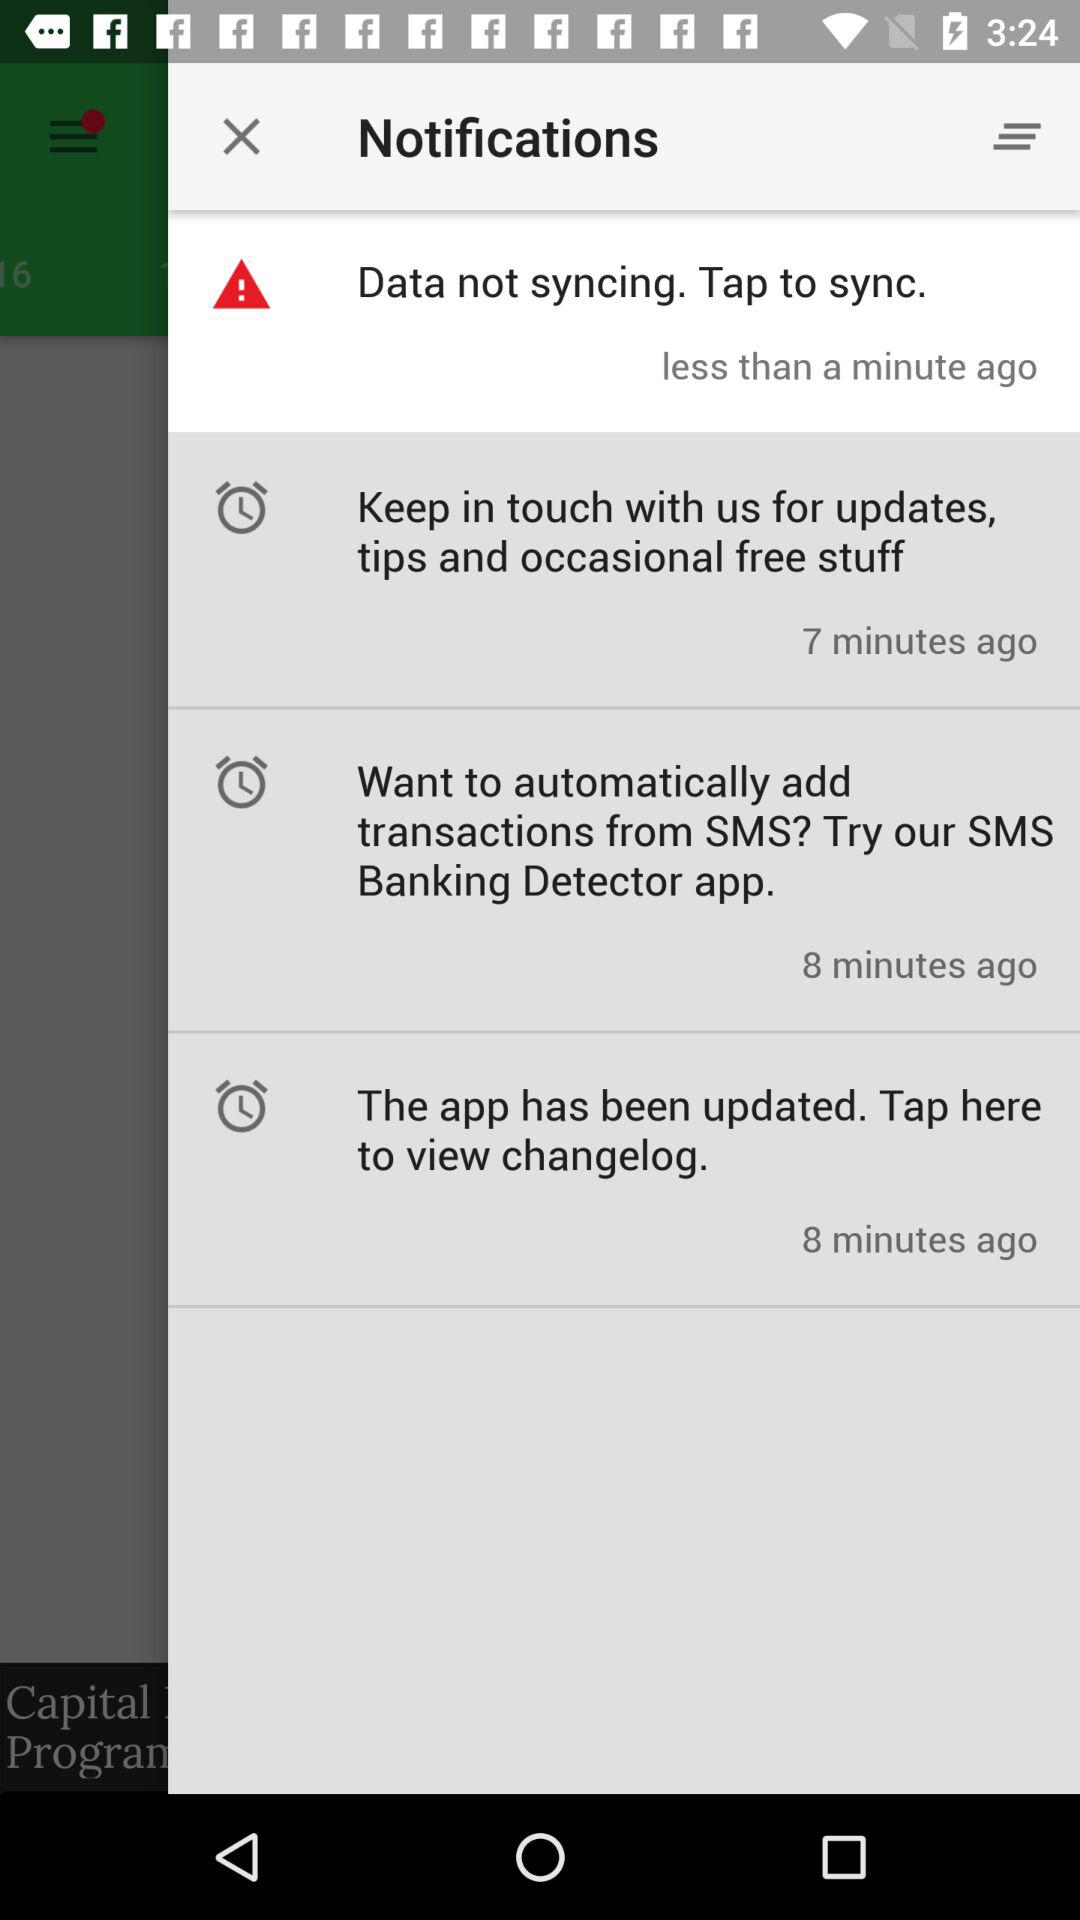When was the app updated? The app was updated 8 minutes ago. 